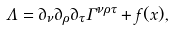Convert formula to latex. <formula><loc_0><loc_0><loc_500><loc_500>\Lambda = \partial _ { \nu } \partial _ { \rho } \partial _ { \tau } \Gamma ^ { \nu \rho \tau } + f ( x ) ,</formula> 